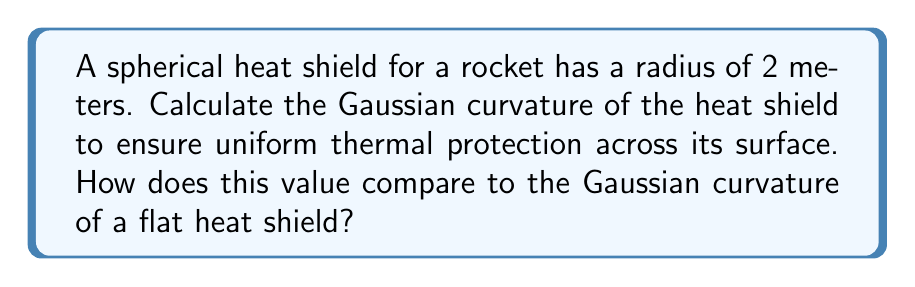Provide a solution to this math problem. To solve this problem, we'll follow these steps:

1) The Gaussian curvature (K) of a surface is the product of its two principal curvatures. For a sphere, these principal curvatures are equal and constant across the entire surface.

2) For a sphere of radius r, the principal curvatures are both equal to $\frac{1}{r}$.

3) Therefore, the Gaussian curvature of a sphere is:

   $$K = \frac{1}{r} \cdot \frac{1}{r} = \frac{1}{r^2}$$

4) In this case, the radius is 2 meters. Let's substitute this into our equation:

   $$K = \frac{1}{2^2} = \frac{1}{4} = 0.25 \text{ m}^{-2}$$

5) To compare this with a flat heat shield, we need to calculate the Gaussian curvature of a plane:

   For a flat surface, both principal curvatures are 0.
   $$K_{flat} = 0 \cdot 0 = 0 \text{ m}^{-2}$$

6) The positive Gaussian curvature of the spherical heat shield (0.25 m^-2) indicates that it's uniformly curved in the same direction at all points, providing consistent thermal protection. In contrast, the flat heat shield has a Gaussian curvature of 0, indicating no curvature and potentially non-uniform thermal protection.
Answer: $K = 0.25 \text{ m}^{-2}$; higher than flat shield's $K = 0 \text{ m}^{-2}$ 